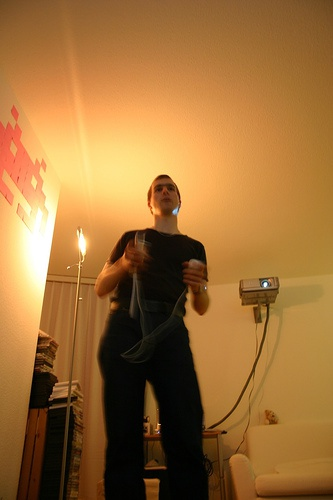Describe the objects in this image and their specific colors. I can see people in maroon, black, and brown tones, couch in maroon and olive tones, book in maroon, black, and brown tones, book in maroon and black tones, and remote in maroon, black, and brown tones in this image. 